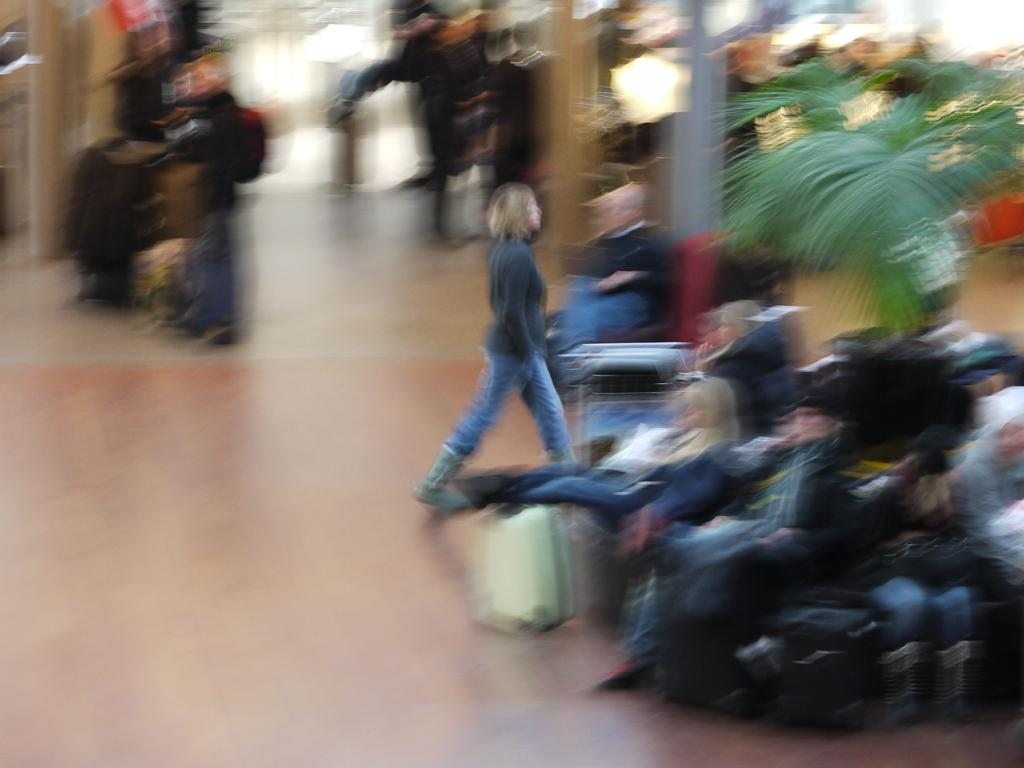What can be seen in the image, despite the blurriness? There are people, luggage, a plant, and the floor visible in the image. Can you describe the people in the image? The image is blurred, so it's difficult to provide specific details about the people. What type of luggage is present in the image? The image is blurred, so it's difficult to provide specific details about the luggage. What can be seen on the floor in the image? The floor is visible in the image, but the blurriness makes it difficult to provide specific details about what is on the floor. How many light bulbs are hanging from the ceiling in the image? There are no light bulbs visible in the image; it only shows people, luggage, a plant, and the floor. What type of minister is present in the image? There is no minister present in the image. 